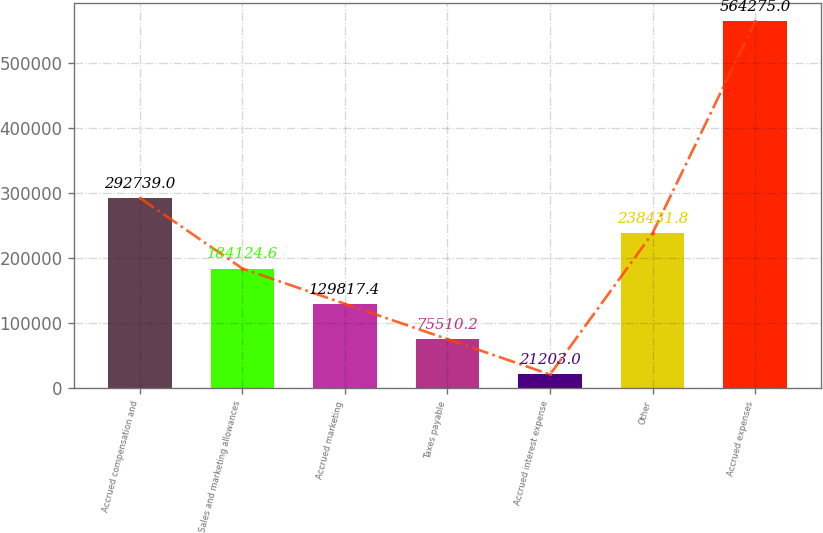Convert chart. <chart><loc_0><loc_0><loc_500><loc_500><bar_chart><fcel>Accrued compensation and<fcel>Sales and marketing allowances<fcel>Accrued marketing<fcel>Taxes payable<fcel>Accrued interest expense<fcel>Other<fcel>Accrued expenses<nl><fcel>292739<fcel>184125<fcel>129817<fcel>75510.2<fcel>21203<fcel>238432<fcel>564275<nl></chart> 